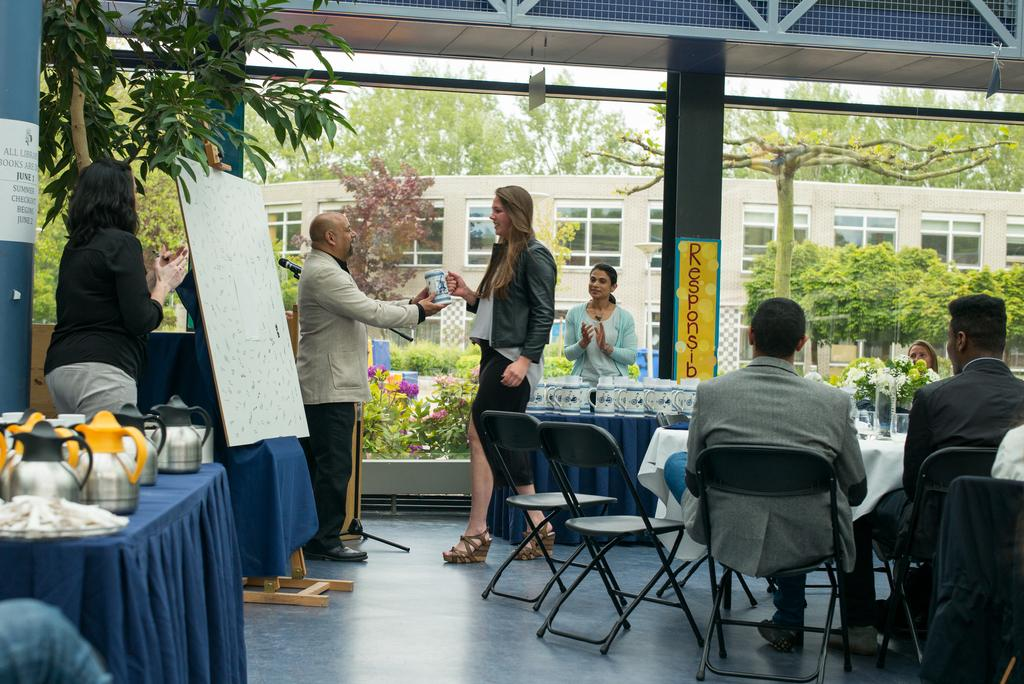What type of structure is visible in the image? There is a building in the image. What natural elements can be seen in the image? There are trees in the image. What are the people in the image doing? There are people seated on chairs in the image. What is the man in the image doing? The man is standing and taking a mug from a woman in the image. What type of nerve is being used by the man to take the mug from the woman? There is no mention of nerves in the image, and the man is simply taking a mug from a woman. What type of brake is present in the image? There is no brake present in the image. 